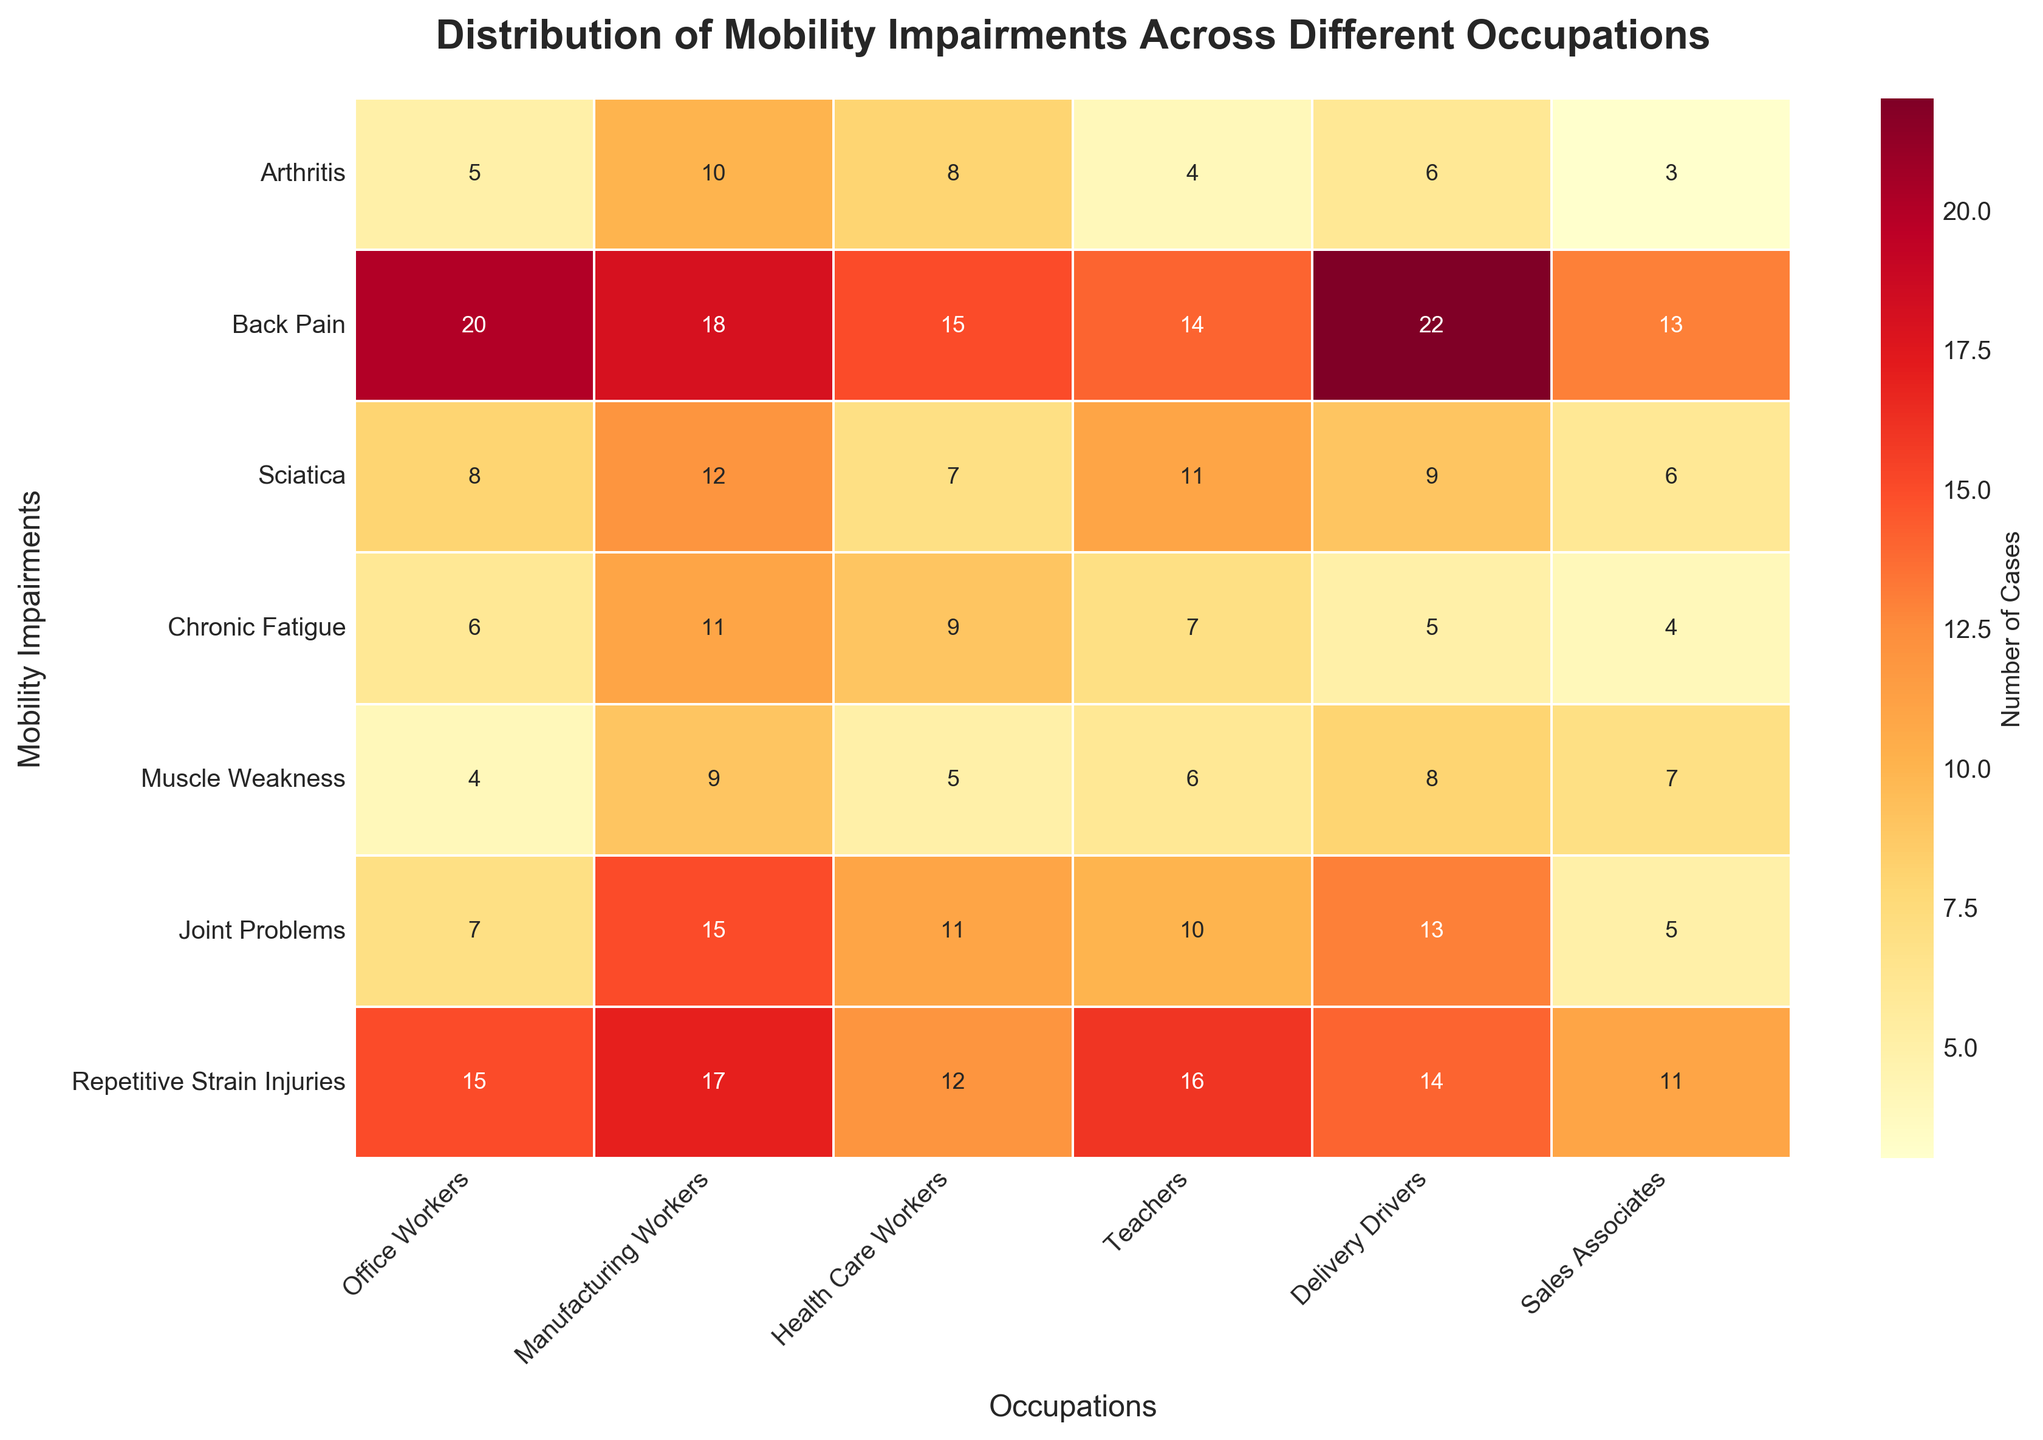What is the title of the heatmap? The title of the heatmap is placed at the top of the figure, which describes the overall content and purpose of the plot. The title reads "Distribution of Mobility Impairments Across Different Occupations."
Answer: Distribution of Mobility Impairments Across Different Occupations According to the heatmap, which occupational group has the highest number of cases of arthritis? To determine which group has the highest number of arthritis cases, look across the row labeled "Arthritis" and identify the highest value. The highest value of 10 is associated with Manufacturing Workers.
Answer: Manufacturing Workers Which mobility impairment is most common among Delivery Drivers? To find the most common impairment for Delivery Drivers, check the column under "Delivery Drivers" and identify the highest value. The highest value in this column is 22, which corresponds to Back Pain.
Answer: Back Pain How many total cases of Sciatica are reported across all occupations? Sum the numbers in the "Sciatica" row to find the total cases across all occupations, i.e., 8 (Office Workers) + 12 (Manufacturing Workers) + 7 (Health Care Workers) + 11 (Teachers) + 9 (Delivery Drivers) + 6 (Sales Associates) = 53
Answer: 53 Compare the number of Chronic Fatigue cases between Office Workers and Sales Associates. Which group has more cases, and by how much? Compare the number of cases of Chronic Fatigue for Office Workers (6) and Sales Associates (4). Office Workers have 6 - 4 = 2 more cases than Sales Associates.
Answer: Office Workers, 2 more cases What is the average number of Repetitive Strain Injuries across all occupations? To find the average, add the values for Repetitive Strain Injuries from all occupations and divide by the number of occupations: (15 + 17 + 12 + 16 + 14 + 11) / 6 = 85 / 6 ≈ 14.17
Answer: 14.17 Which occupation has the lowest number of cases for Muscle Weakness, and what is the value? To find the lowest number of Muscle Weakness cases, check the row labeled "Muscle Weakness" and identify the smallest value, which is 4 for Office Workers.
Answer: Office Workers, 4 For Health Care Workers, which impairment has the second highest number of cases, and what is the value? Look at the column under "Health Care Workers" and find the second highest value. The highest is Back Pain with 15, so the second highest is Joint Problems with 11.
Answer: Joint Problems, 11 Is there any occupational group where Chronic Fatigue is the most reported impairment? Check each column for the maximum value in the “Chronic Fatigue” row and compare with the other values in the same column. Chronic Fatigue is not the highest in any group.
Answer: No 